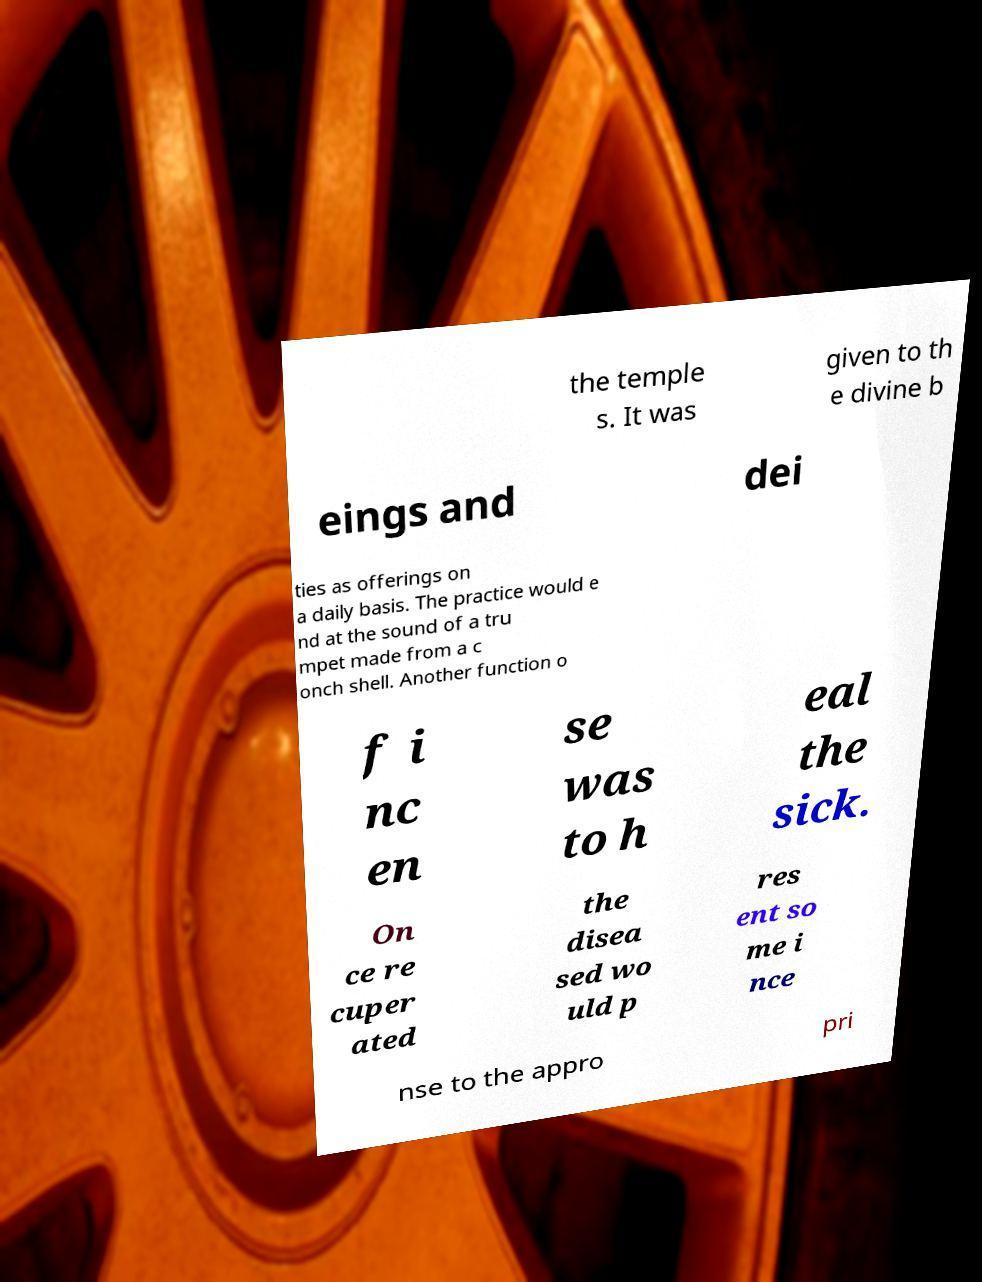Please identify and transcribe the text found in this image. the temple s. It was given to th e divine b eings and dei ties as offerings on a daily basis. The practice would e nd at the sound of a tru mpet made from a c onch shell. Another function o f i nc en se was to h eal the sick. On ce re cuper ated the disea sed wo uld p res ent so me i nce nse to the appro pri 